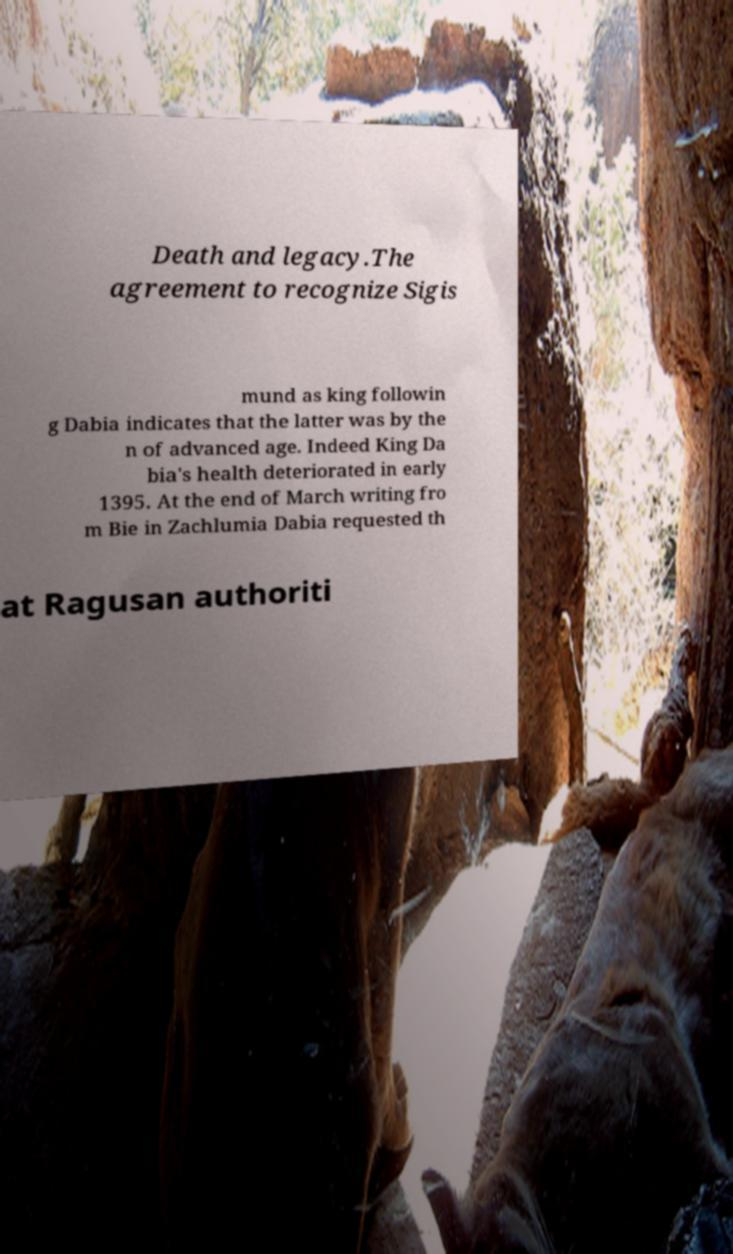There's text embedded in this image that I need extracted. Can you transcribe it verbatim? Death and legacy.The agreement to recognize Sigis mund as king followin g Dabia indicates that the latter was by the n of advanced age. Indeed King Da bia's health deteriorated in early 1395. At the end of March writing fro m Bie in Zachlumia Dabia requested th at Ragusan authoriti 